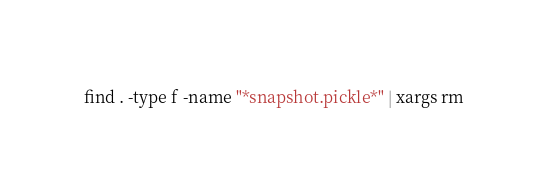Convert code to text. <code><loc_0><loc_0><loc_500><loc_500><_Bash_>find . -type f -name "*snapshot.pickle*" | xargs rm
</code> 